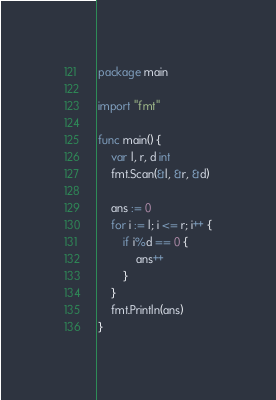Convert code to text. <code><loc_0><loc_0><loc_500><loc_500><_Go_>package main

import "fmt"

func main() {
	var l, r, d int
	fmt.Scan(&l, &r, &d)

	ans := 0
	for i := l; i <= r; i++ {
		if i%d == 0 {
			ans++
		}
	}
	fmt.Println(ans)
}
</code> 